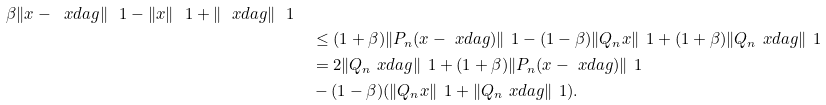Convert formula to latex. <formula><loc_0><loc_0><loc_500><loc_500>{ \beta \| x - \ x d a g \| _ { \ } 1 - \| x \| _ { \ } 1 + \| \ x d a g \| _ { \ } 1 } \\ & \quad \leq ( 1 + \beta ) \| P _ { n } ( x - \ x d a g ) \| _ { \ } 1 - ( 1 - \beta ) \| Q _ { n } x \| _ { \ } 1 + ( 1 + \beta ) \| Q _ { n } \ x d a g \| _ { \ } 1 \\ & \quad = 2 \| Q _ { n } \ x d a g \| _ { \ } 1 + ( 1 + \beta ) \| P _ { n } ( x - \ x d a g ) \| _ { \ } 1 \\ & \quad - ( 1 - \beta ) ( \| Q _ { n } x \| _ { \ } 1 + \| Q _ { n } \ x d a g \| _ { \ } 1 ) .</formula> 